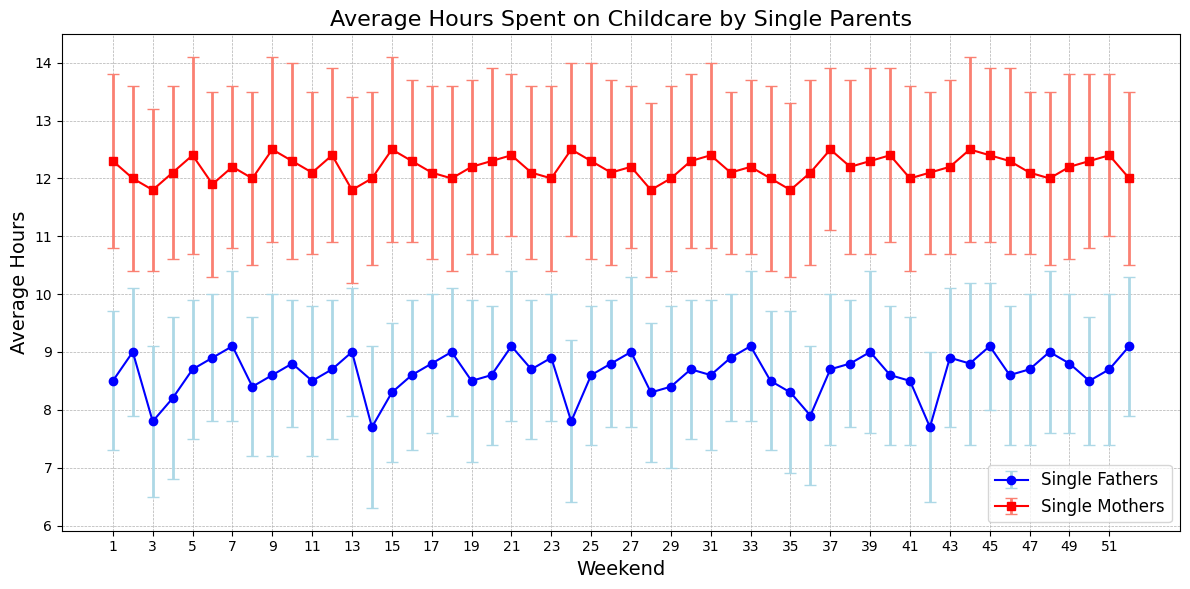How many weekends do single mothers spend more time on childcare than single fathers? To find the number of weekends where single mothers spend more time on childcare than single fathers, we compare the average hours for each weekend. It is evident from the plot that single mothers spend more time on childcare than single fathers on all weekends.
Answer: 52 On which weekend is the difference in hours spent on childcare between single mothers and single fathers the highest? To identify the weekend with the greatest difference in childcare hours, we calculate the difference for each weekend and find the maximum. The maximum difference is seen on weekend 1, where single mothers spend (12.3 - 8.5) = 3.8 more hours than single fathers.
Answer: Weekend 1 Which group shows a more consistent pattern in childcare hours, single fathers or single mothers? Consistency can be inferred from the size of the error bars and the variability in average hours. Single fathers show more consistency because their error bars (uncertainty) are generally smaller and their average hours vary less compared to single mothers.
Answer: Single fathers What is the average number of hours spent on childcare by single fathers over the first 10 weekends? To compute the average over the first 10 weekends, sum the average hours and divide by 10. (8.5 + 9.0 + 7.8 + 8.2 + 8.7 + 8.9 + 9.1 + 8.4 + 8.6 + 8.8) / 10 = 8.6
Answer: 8.6 Which weekends have single mothers spending an average of 12 hours or more on childcare? By scanning the plot, we look for points where single mothers' average hours are ≥ 12. These weekends are: 1, 2, 4, 5, 7, 9, 10, 11, 12, 13, 15, 16, 17, 19, 20, 21, 22, 23, 24, 25, 26, 27, 30, 31, 33, 35, 37, 38, 39, 40, 43, 44, 45, 46, 48, 49, 50, 51, 52.
Answer: Multiple (37 out of 52) Which weekend shows the least difference in childcare hours between single mothers and single fathers? We calculate the absolute difference for each weekend and find the minimum. The smallest difference occurs in weekend 14, where the difference is 12.0 - 7.7 = 4.3 hours.
Answer: Weekend 14 Compare the error bars for single fathers and single mothers in weekend 36. Which group shows greater variability? The error bars for single fathers and single mothers in weekend 36 are both visible. The lighter blue lines indicate single fathers and the salmon lines indicate single mothers. Single mothers have larger error bars, indicating greater variability.
Answer: Single mothers 